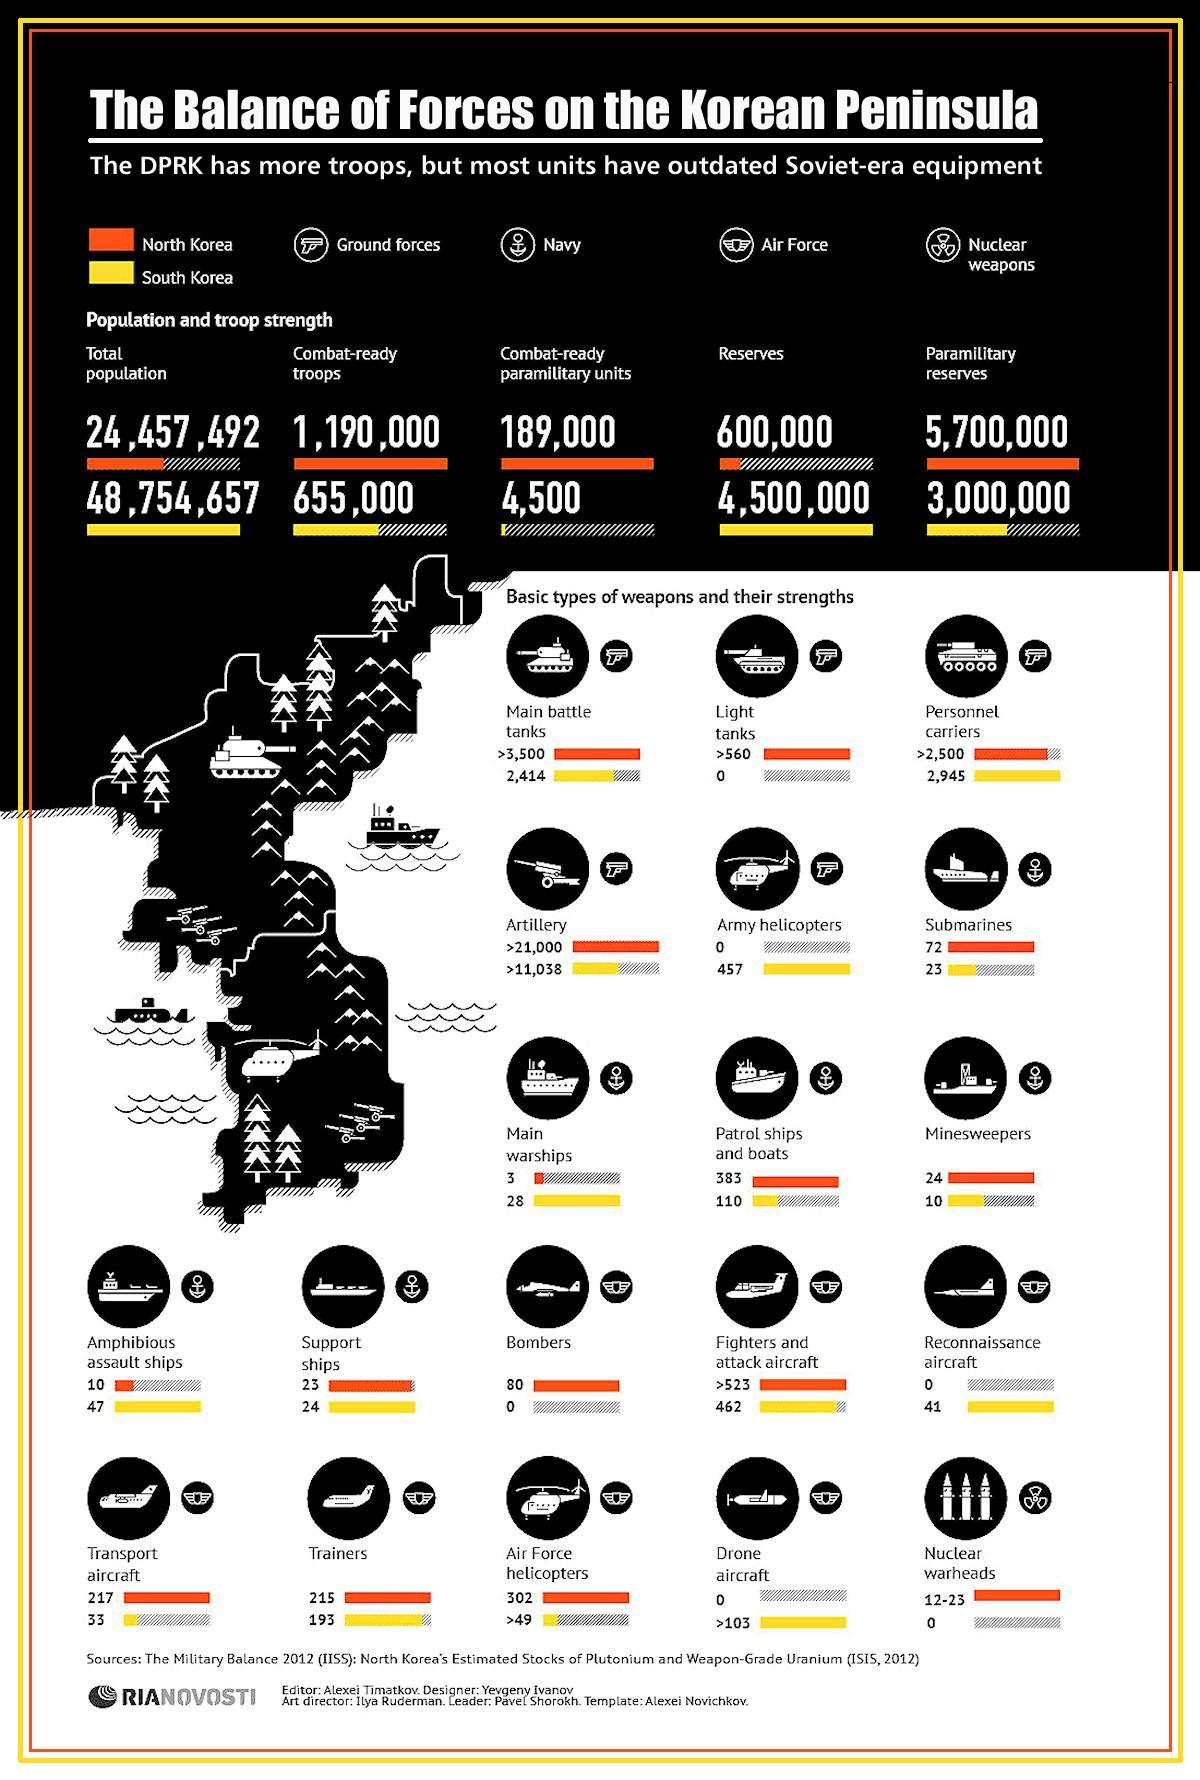Point out several critical features in this image. South Korea has more warships than North Korea. South Korea owns 457 army helicopters. North Korea is believed to own 72 submarines. North Korea has a greater number of light tanks compared to other countries. This infographic provides a comparison of the amount of air force resources allocated to various countries. 